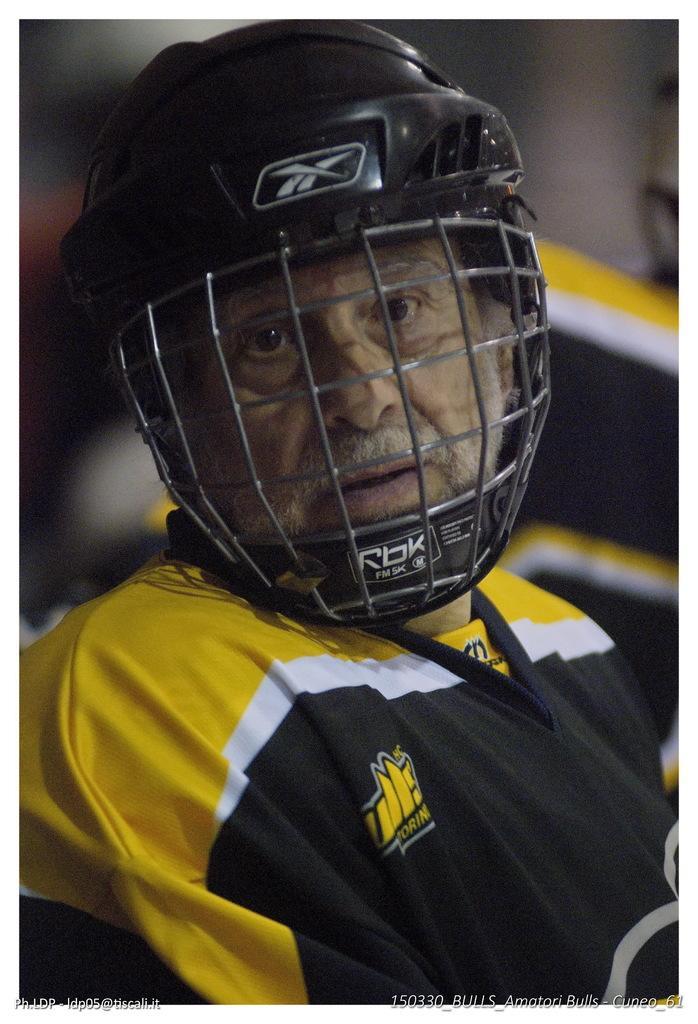How would you summarize this image in a sentence or two? In this picture there is a man in the center of the image, he is wearing a helmet and the background area of the image is blurred. 